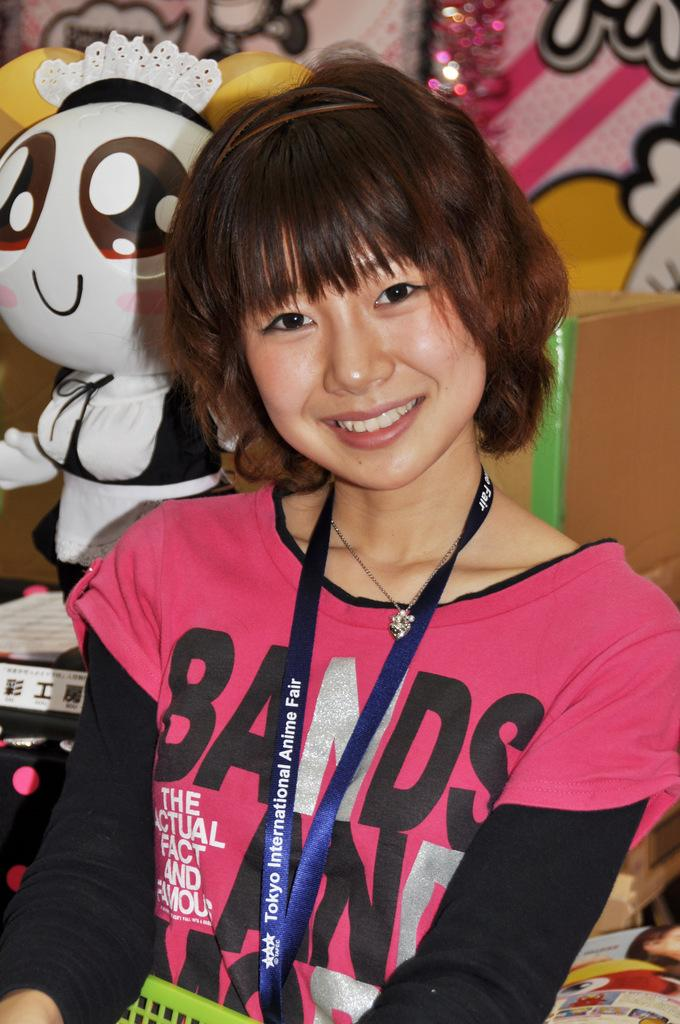Who is the main subject in the image? There is a girl in the middle of the image. What is the girl doing in the image? The girl is smiling. What can be seen on the left side of the image? There is a doll on the left side of the image. What is visible in the background of the image? There are paintings on the wall in the background of the image. What type of zipper can be seen on the girl's clothing in the image? There is no zipper visible on the girl's clothing in the image. What process is the girl following in the image? The image does not depict a specific process; it simply shows the girl smiling. 